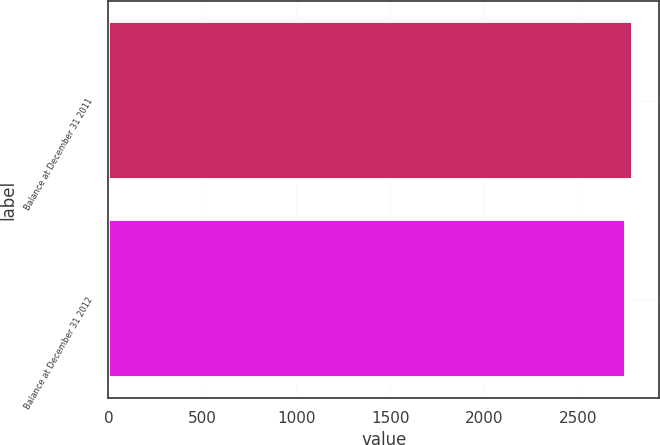Convert chart to OTSL. <chart><loc_0><loc_0><loc_500><loc_500><bar_chart><fcel>Balance at December 31 2011<fcel>Balance at December 31 2012<nl><fcel>2792<fcel>2758<nl></chart> 